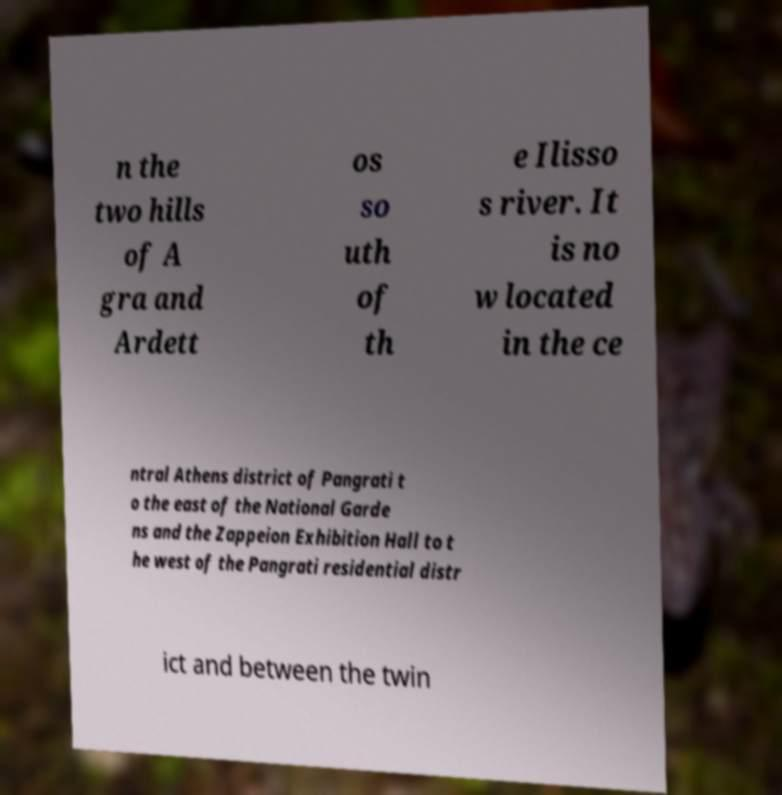Can you read and provide the text displayed in the image?This photo seems to have some interesting text. Can you extract and type it out for me? n the two hills of A gra and Ardett os so uth of th e Ilisso s river. It is no w located in the ce ntral Athens district of Pangrati t o the east of the National Garde ns and the Zappeion Exhibition Hall to t he west of the Pangrati residential distr ict and between the twin 